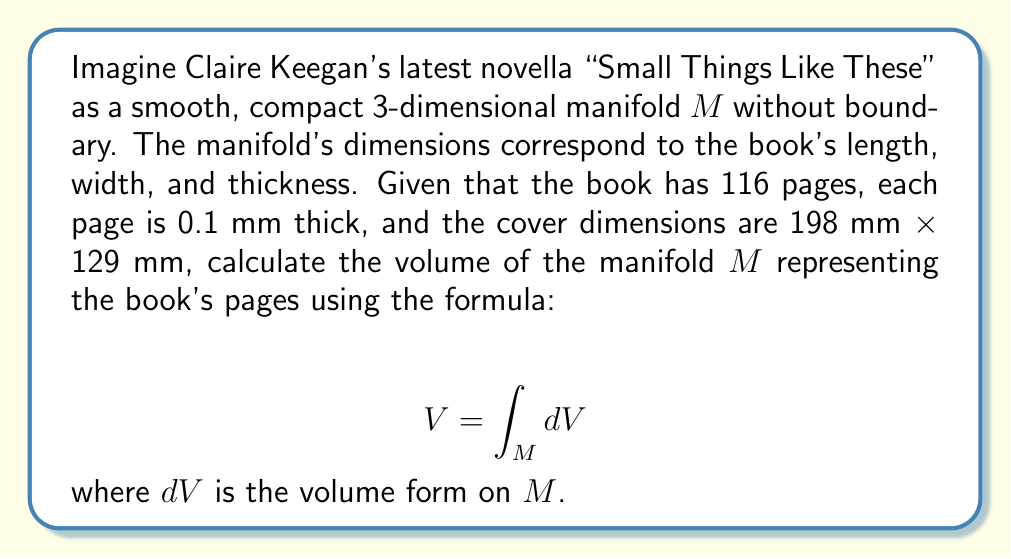Give your solution to this math problem. To solve this problem, we need to follow these steps:

1) First, we need to understand what the manifold $M$ represents. In this case, $M$ is a 3-dimensional object representing the pages of the book (excluding the cover).

2) The volume of a manifold can be calculated using the integral of the volume form $dV$ over the entire manifold. In this case, since our manifold is a simple rectangular prism, we can use the standard formula for volume:

   $$V = length \times width \times thickness$$

3) We are given the following information:
   - Length = 198 mm
   - Width = 129 mm
   - Number of pages = 116
   - Thickness of each page = 0.1 mm

4) To find the total thickness of the book's pages, we multiply the number of pages by the thickness of each page:
   
   $$thickness = 116 \times 0.1 \text{ mm} = 11.6 \text{ mm}$$

5) Now we can calculate the volume:

   $$V = 198 \text{ mm} \times 129 \text{ mm} \times 11.6 \text{ mm}$$

6) Multiplying these values:

   $$V = 296,956.8 \text{ mm}^3$$

7) Converting to cm³:

   $$V = 296.9568 \text{ cm}^3$$

This result represents the volume of the manifold $M$, which in this case is equivalent to the volume of the book's pages.
Answer: The volume of the manifold $M$ representing the pages of Claire Keegan's "Small Things Like These" is approximately 296.96 cm³. 